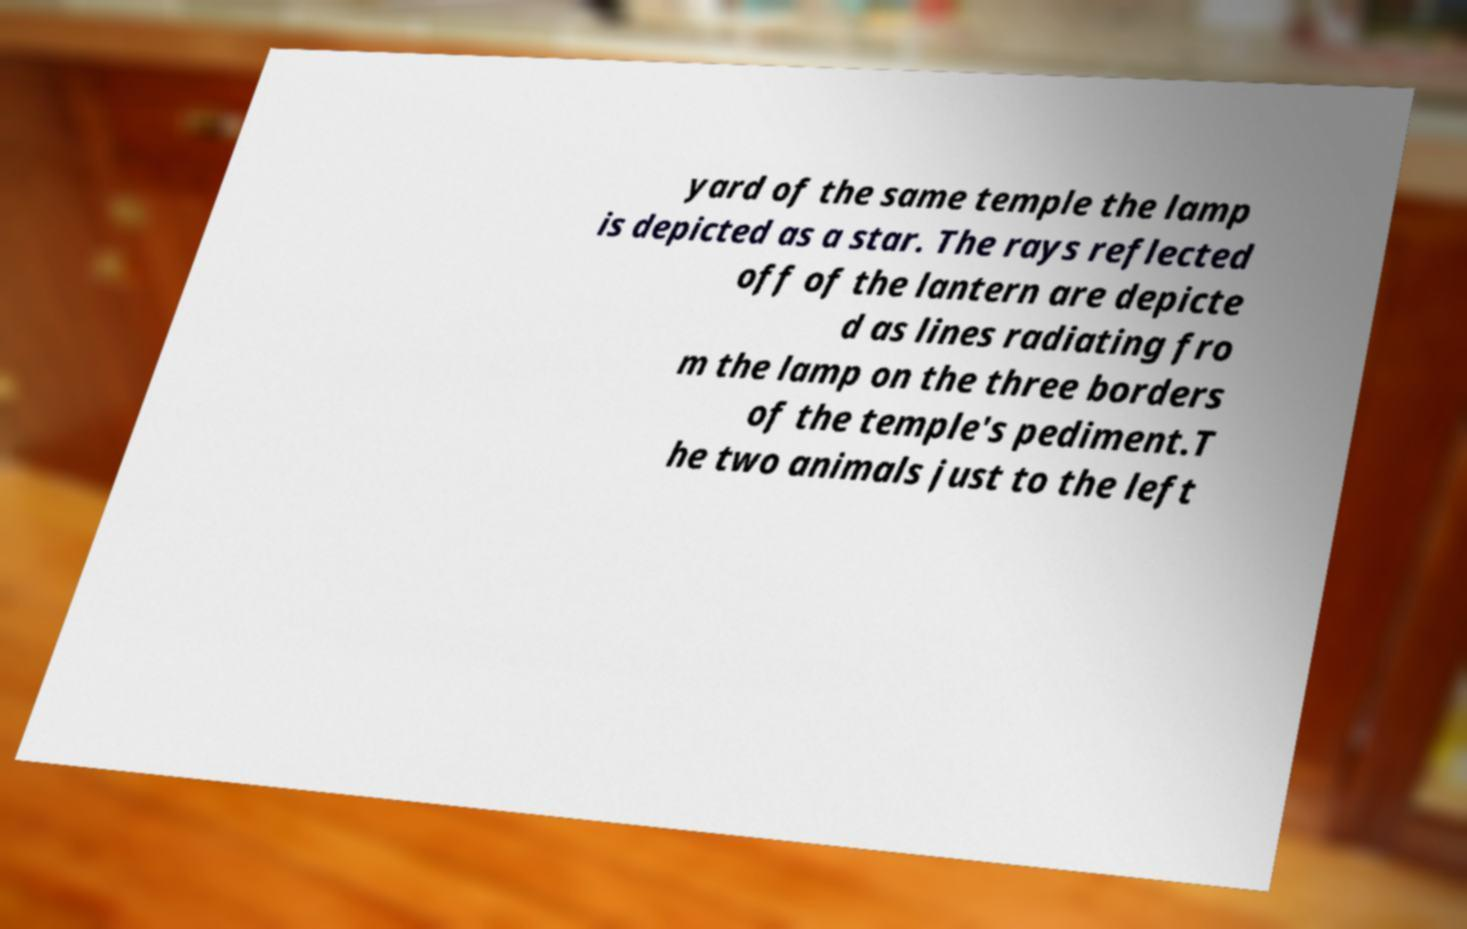I need the written content from this picture converted into text. Can you do that? yard of the same temple the lamp is depicted as a star. The rays reflected off of the lantern are depicte d as lines radiating fro m the lamp on the three borders of the temple's pediment.T he two animals just to the left 